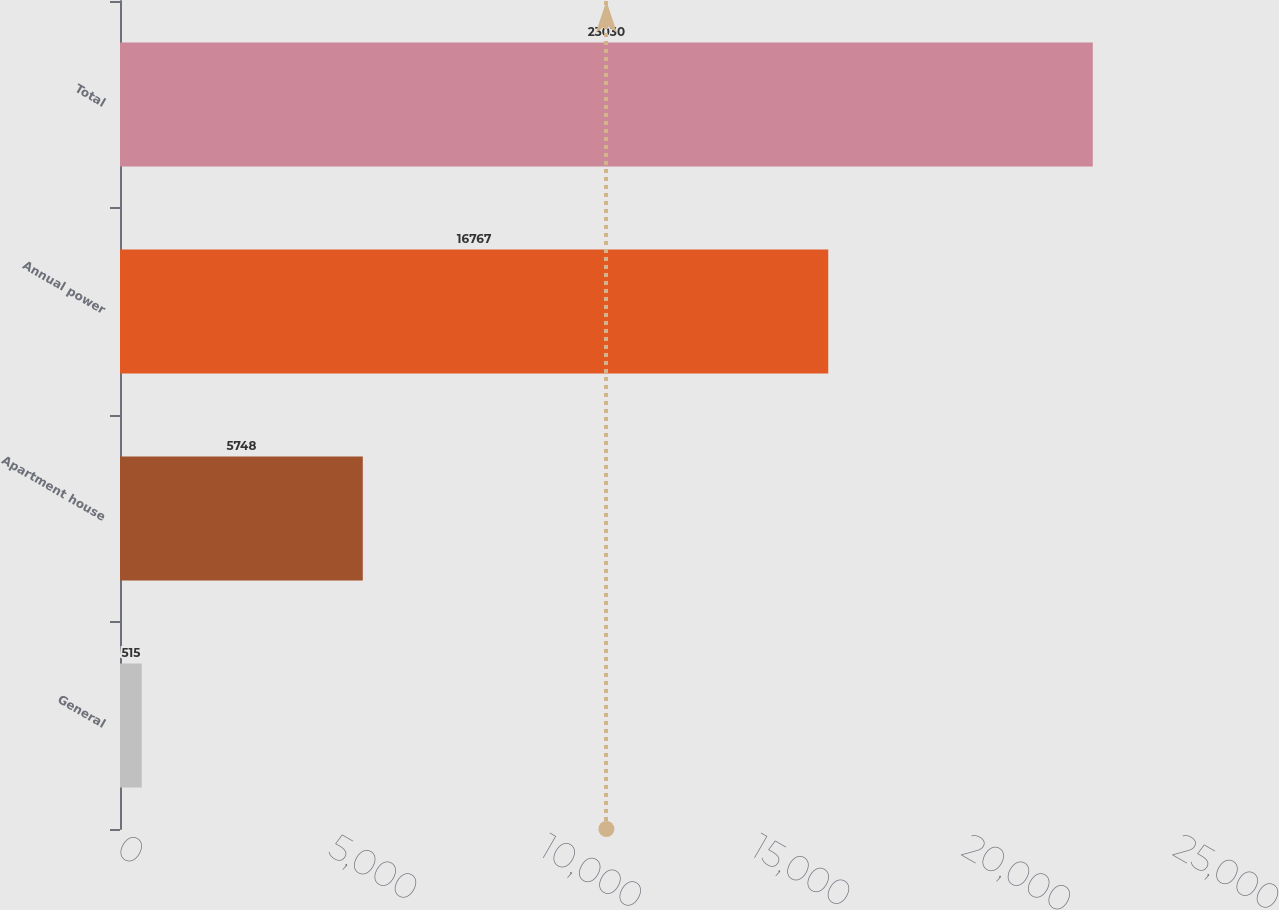Convert chart. <chart><loc_0><loc_0><loc_500><loc_500><bar_chart><fcel>General<fcel>Apartment house<fcel>Annual power<fcel>Total<nl><fcel>515<fcel>5748<fcel>16767<fcel>23030<nl></chart> 